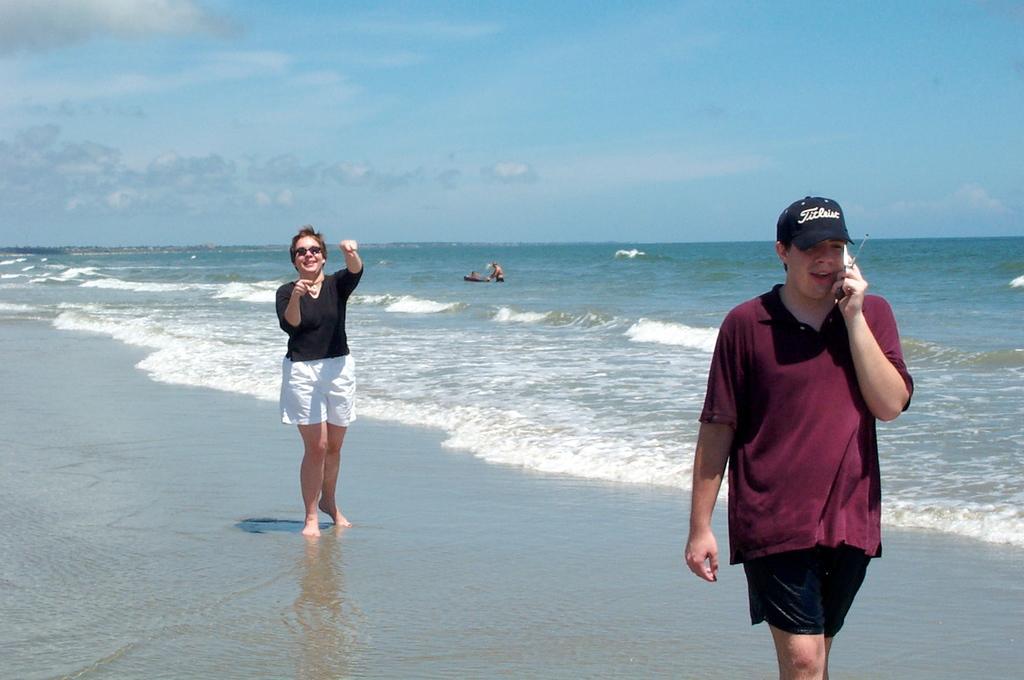In one or two sentences, can you explain what this image depicts? In this image I can see three people at a sea shore two people standing outside the water one person in the water, person on the right hand side is talking on the phone. At the top of the image I can see the sky. 